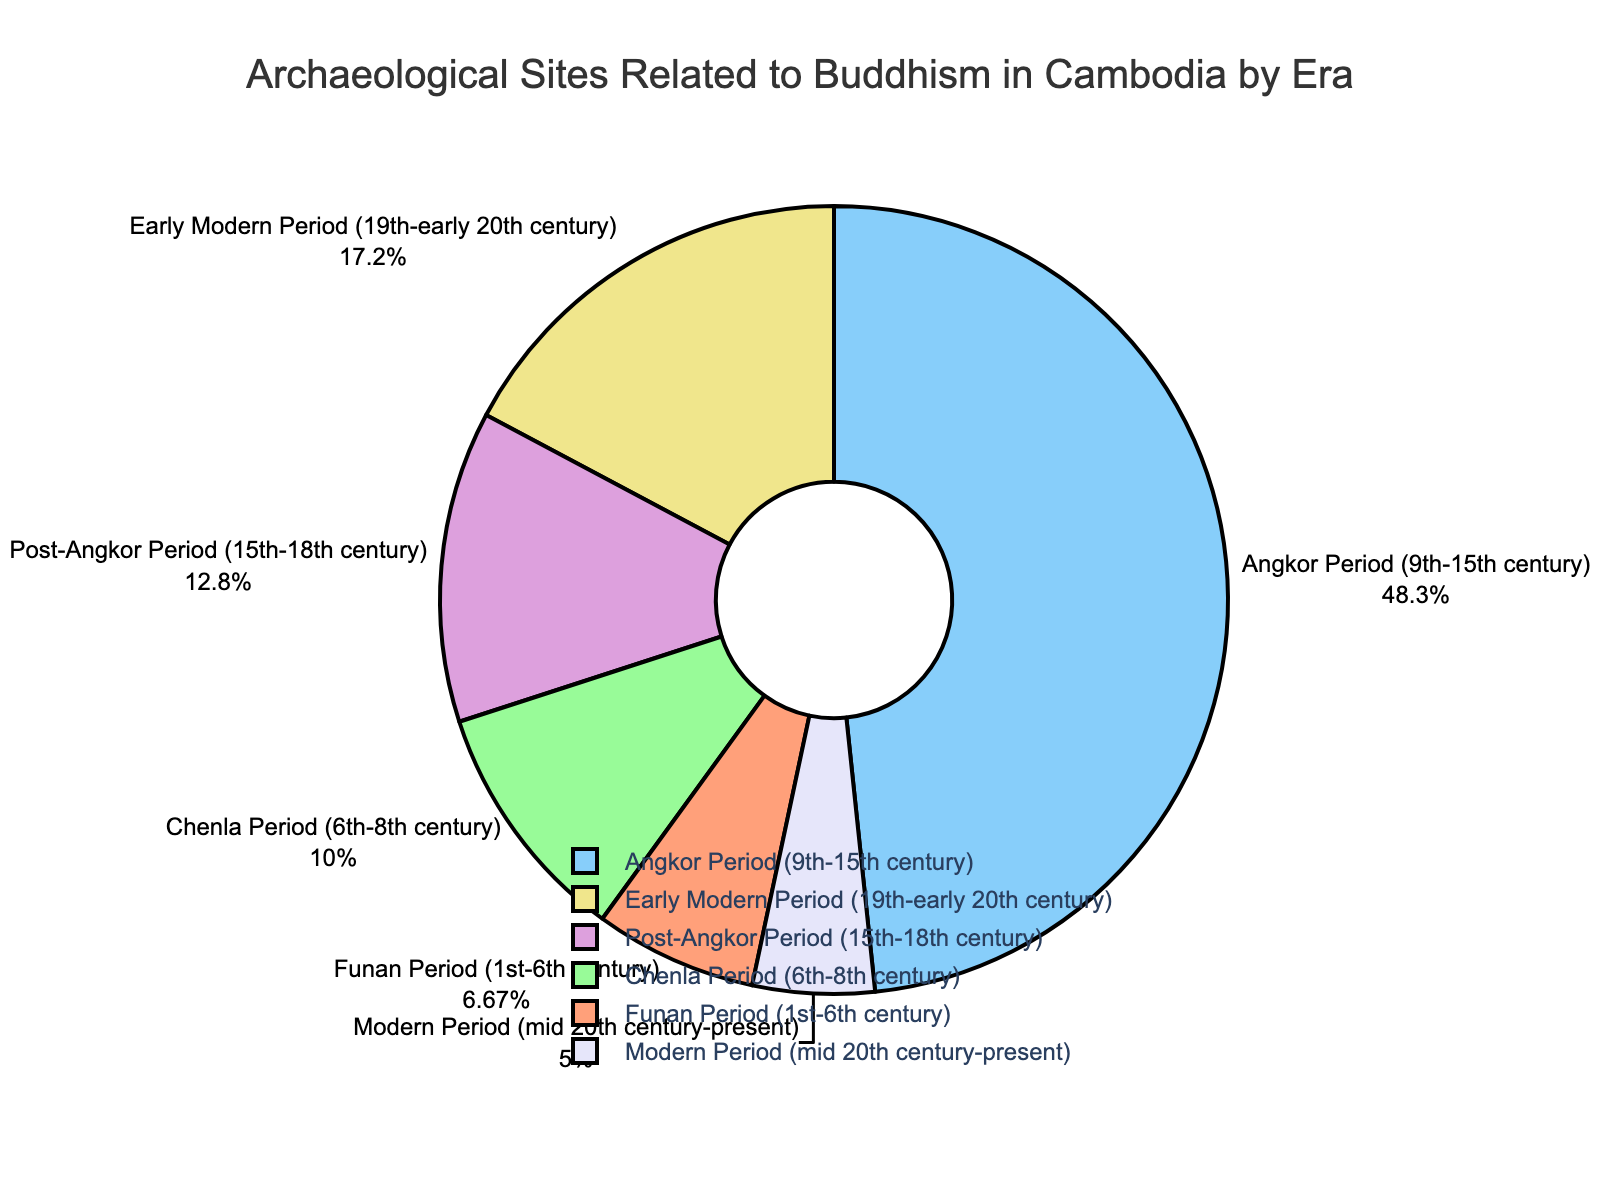What era has the highest number of archaeological sites related to Buddhism? The pie chart shows the Angkor Period has the largest section. This indicates that the Angkor Period has the highest number of sites with 87.
Answer: Angkor Period Which era has the smallest percentage of archaeological sites related to Buddhism? From the pie chart, the Modern Period's section is the smallest, showing it has the lowest number of sites with 9.
Answer: Modern Period What is the total number of archaeological sites related to Buddhism from the Chenla and Angkor periods combined? The number of sites for Chenla Period is 18 and for Angkor Period is 87. Summing these gives 18 + 87 = 105.
Answer: 105 Compare the number of archaeological sites between the Post-Angkor Period and the Early Modern Period. Which era has more sites? The pie chart shows that the Early Modern Period (31 sites) has a larger section than the Post-Angkor Period (23 sites), indicating more sites in the Early Modern Period.
Answer: Early Modern Period What color represents the Early Modern Period in the pie chart? By examining the chart, it is observed that the Early Modern Period is represented by the color purple.
Answer: Purple How does the number of sites in the Funan Period compare to the Modern Period? The Funan Period has 12 sites, while the Modern Period has 9 sites. Therefore, the Funan Period has more sites than the Modern Period.
Answer: Funan Period What is the combined percentage of archaeological sites from the Funan and Modern Periods? The Funan Period and Modern Period have 12 and 9 sites respectively. Summing their sites gives 12 + 9 = 21. The total number of sites is 180. The percentage is (21/180) * 100 ≈ 11.67%.
Answer: 11.67% If you sum the numbers of archaeological sites for the Funan, Chenla, and Modern periods, how many total sites do you get? Funan Period has 12 sites, Chenla Period has 18 sites, and Modern Period has 9 sites. Adding them, we get 12 + 18 + 9 = 39.
Answer: 39 